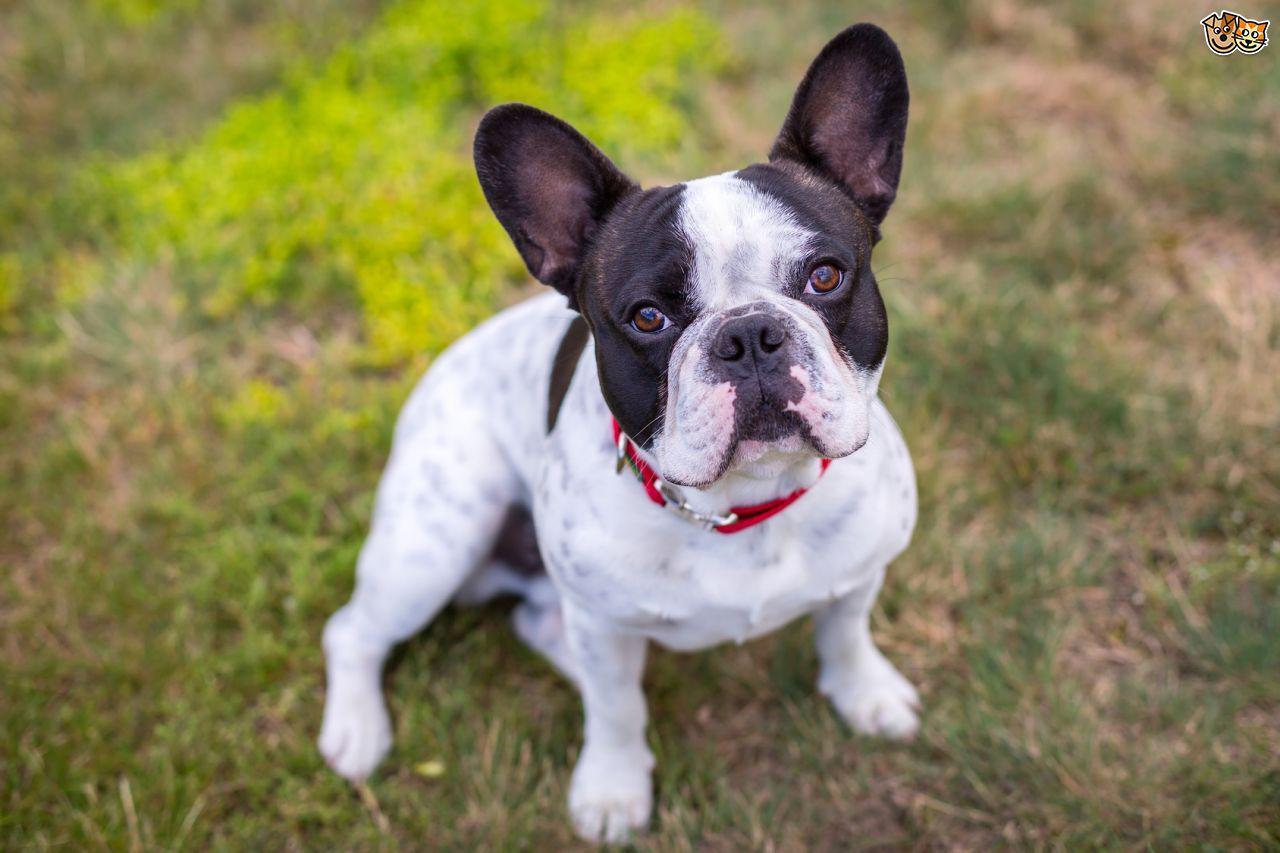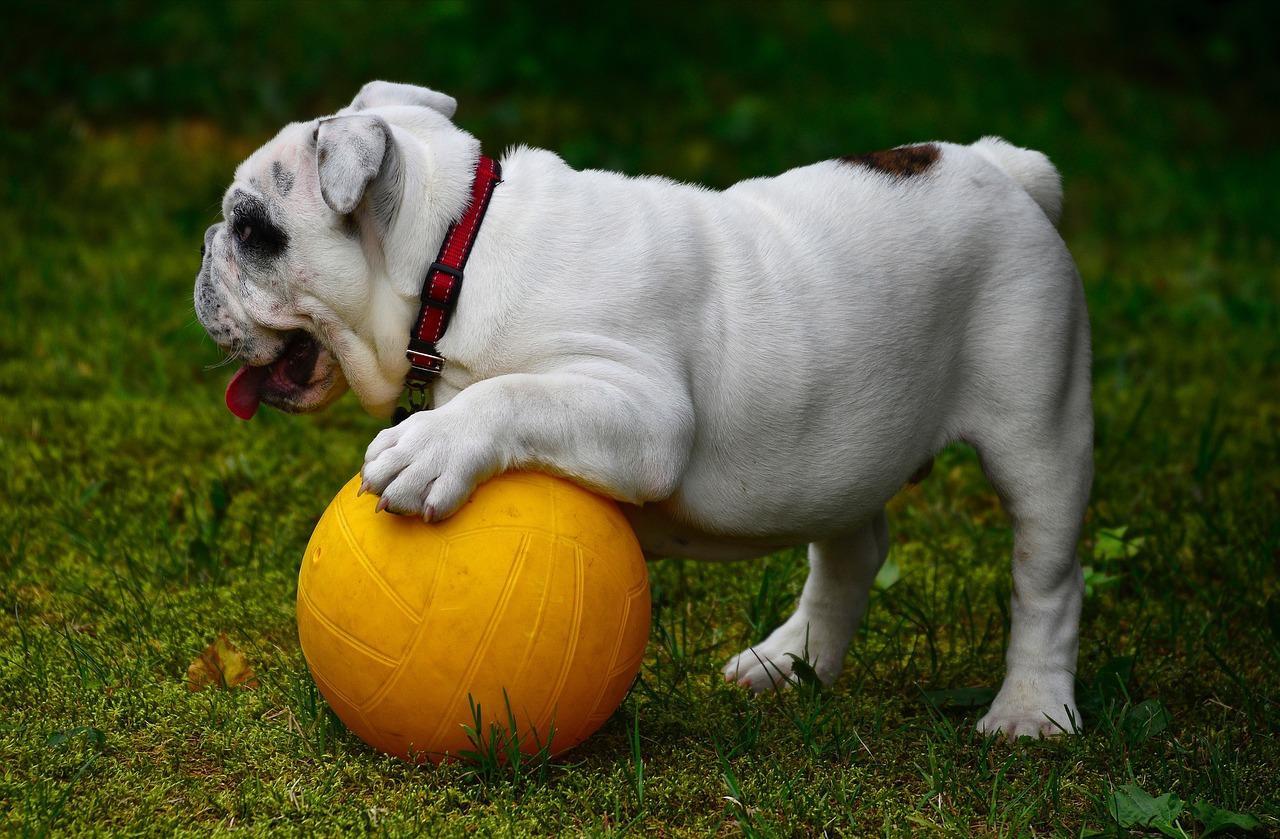The first image is the image on the left, the second image is the image on the right. For the images displayed, is the sentence "The left image contains exactly two dogs." factually correct? Answer yes or no. No. The first image is the image on the left, the second image is the image on the right. Examine the images to the left and right. Is the description "In one image, a dog has its paw resting on top of a ball" accurate? Answer yes or no. Yes. 